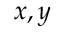Convert formula to latex. <formula><loc_0><loc_0><loc_500><loc_500>x , y</formula> 